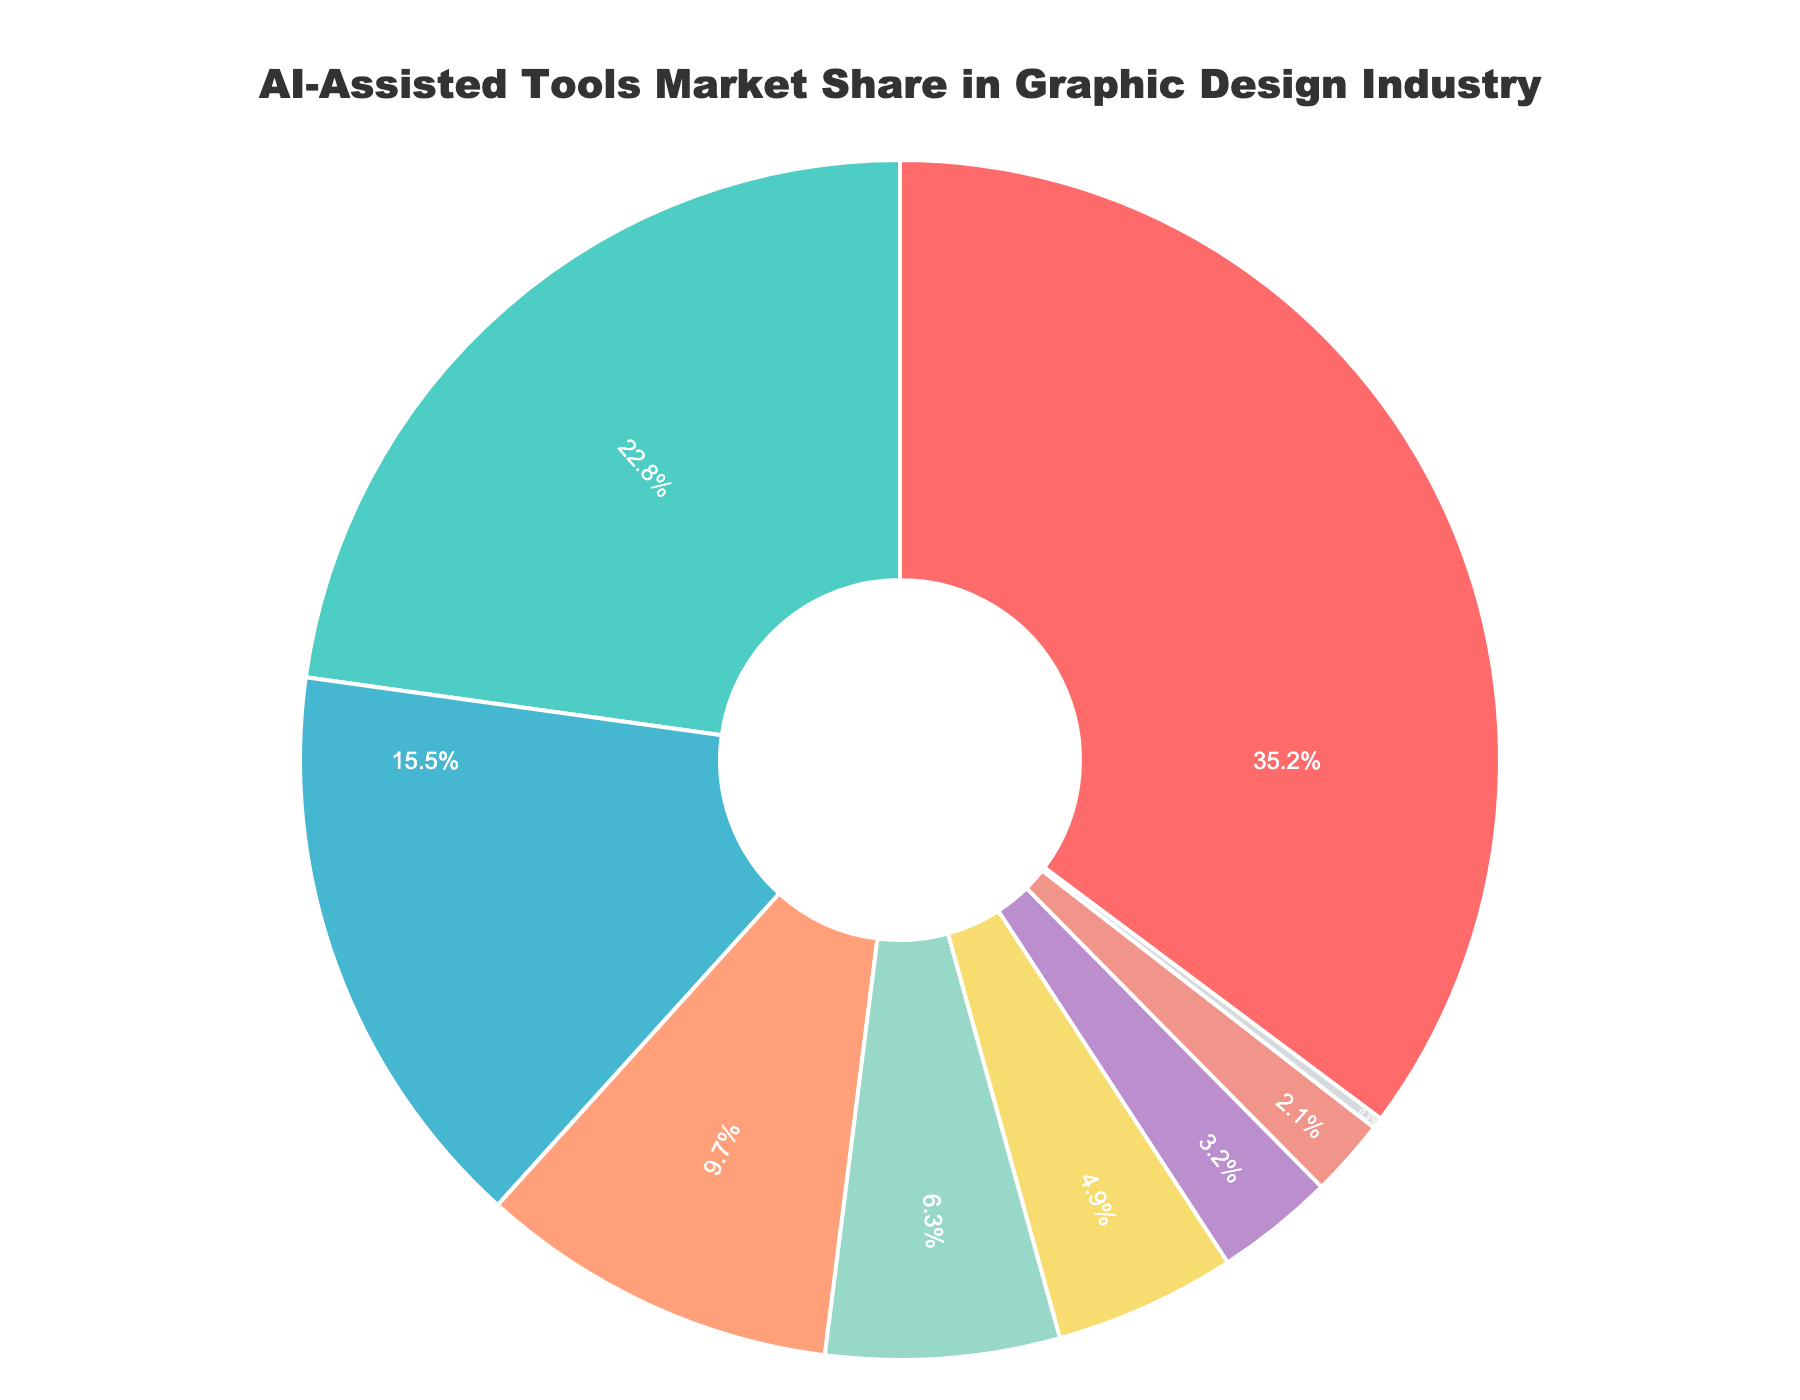What tool has the highest market share? The pie chart shows several tools with different market shares. The tool with the highest market share is the one with the largest section. "Adobe Creative Cloud with Sensei" has the largest section, indicating it holds the highest market share.
Answer: Adobe Creative Cloud with Sensei Which tool has the smallest market share? The section with the smallest size on the pie chart represents the tool with the lowest market share. According to the figure, "Traditional non-AI tools" has the smallest section.
Answer: Traditional non-AI tools What's the combined market share of "Canva with AI Design Assistant" and "Figma with AI features"? To find the combined market share of these two tools, add their individual market shares: 22.8% (Canva) + 15.5% (Figma) = 38.3%.
Answer: 38.3% Compare the market shares of "Sketch with AI plugins" and "Affinity Designer." Which is higher and by how much? From the pie chart, "Sketch with AI plugins" has a market share of 9.7%, and "Affinity Designer" has a market share of 6.3%. The difference can be calculated as 9.7% - 6.3% = 3.4%.
Answer: Sketch with AI plugins, by 3.4% How much larger is the market share of "Adobe Creative Cloud with Sensei" compared to "Procreate"? Identify the market shares from the chart: "Adobe Creative Cloud with Sensei" is 35.2%, and "Procreate" is 2.1%. The difference is calculated as 35.2% - 2.1% = 33.1%.
Answer: 33.1% What’s the total market share of "CorelDRAW with AI tools" and "Autodesk SketchBook" if combined? Sum the market shares of "CorelDRAW with AI tools" (4.9%) and "Autodesk SketchBook" (3.2%): 4.9% + 3.2% = 8.1%.
Answer: 8.1% Which tool represents more than 30% of the market share, and what is its exact percentage? The pie chart shows that only one tool's section is significantly larger, representing over 30%. "Adobe Creative Cloud with Sensei" has a market share of 35.2%.
Answer: Adobe Creative Cloud with Sensei, 35.2% Compare the visual size of the sections representing "Figma with AI features" and "CorelDRAW with AI tools." Which one is larger? The size of the sections on the pie chart directly correlates to the market share each tool holds. "Figma with AI features" has a market share of 15.5%, and "CorelDRAW with AI tools" has 4.9%. Therefore, "Figma with AI features" has a larger visual section.
Answer: Figma with AI features Is there any tool with exactly 3% market share? Reviewing the percentages listed within the chart, no tool has an exact market share of 3%.
Answer: No 